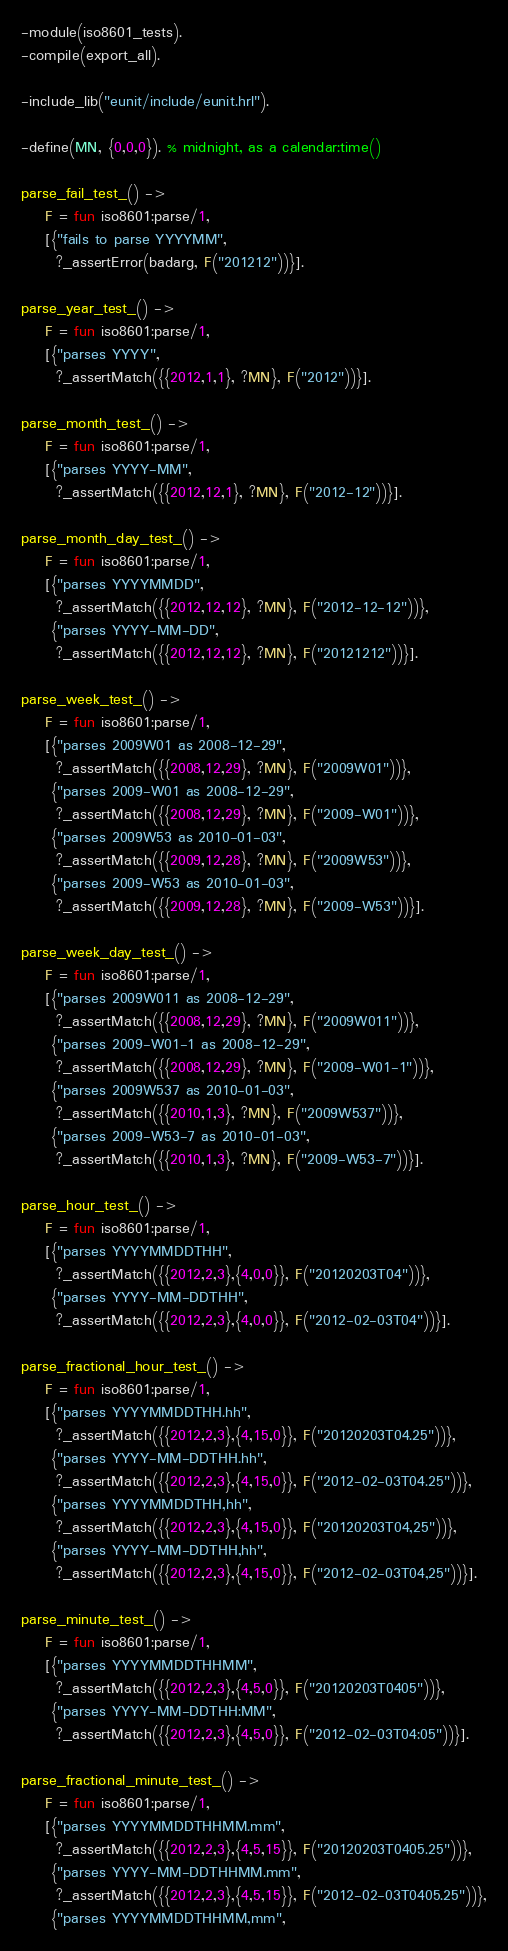Convert code to text. <code><loc_0><loc_0><loc_500><loc_500><_Erlang_>-module(iso8601_tests).
-compile(export_all).

-include_lib("eunit/include/eunit.hrl").

-define(MN, {0,0,0}). % midnight, as a calendar:time()

parse_fail_test_() ->
    F = fun iso8601:parse/1,
    [{"fails to parse YYYYMM",
      ?_assertError(badarg, F("201212"))}].

parse_year_test_() ->
    F = fun iso8601:parse/1,
    [{"parses YYYY",
      ?_assertMatch({{2012,1,1}, ?MN}, F("2012"))}].

parse_month_test_() ->
    F = fun iso8601:parse/1,
    [{"parses YYYY-MM",
      ?_assertMatch({{2012,12,1}, ?MN}, F("2012-12"))}].

parse_month_day_test_() ->
    F = fun iso8601:parse/1,
    [{"parses YYYYMMDD",
      ?_assertMatch({{2012,12,12}, ?MN}, F("2012-12-12"))},
     {"parses YYYY-MM-DD",
      ?_assertMatch({{2012,12,12}, ?MN}, F("20121212"))}].

parse_week_test_() ->
    F = fun iso8601:parse/1,
    [{"parses 2009W01 as 2008-12-29",
      ?_assertMatch({{2008,12,29}, ?MN}, F("2009W01"))},
     {"parses 2009-W01 as 2008-12-29",
      ?_assertMatch({{2008,12,29}, ?MN}, F("2009-W01"))},
     {"parses 2009W53 as 2010-01-03",
      ?_assertMatch({{2009,12,28}, ?MN}, F("2009W53"))},
     {"parses 2009-W53 as 2010-01-03",
      ?_assertMatch({{2009,12,28}, ?MN}, F("2009-W53"))}].

parse_week_day_test_() ->
    F = fun iso8601:parse/1,
    [{"parses 2009W011 as 2008-12-29",
      ?_assertMatch({{2008,12,29}, ?MN}, F("2009W011"))},
     {"parses 2009-W01-1 as 2008-12-29",
      ?_assertMatch({{2008,12,29}, ?MN}, F("2009-W01-1"))},
     {"parses 2009W537 as 2010-01-03",
      ?_assertMatch({{2010,1,3}, ?MN}, F("2009W537"))},
     {"parses 2009-W53-7 as 2010-01-03",
      ?_assertMatch({{2010,1,3}, ?MN}, F("2009-W53-7"))}].

parse_hour_test_() ->
    F = fun iso8601:parse/1,
    [{"parses YYYYMMDDTHH",
      ?_assertMatch({{2012,2,3},{4,0,0}}, F("20120203T04"))},
     {"parses YYYY-MM-DDTHH",
      ?_assertMatch({{2012,2,3},{4,0,0}}, F("2012-02-03T04"))}].

parse_fractional_hour_test_() ->
    F = fun iso8601:parse/1,
    [{"parses YYYYMMDDTHH.hh",
      ?_assertMatch({{2012,2,3},{4,15,0}}, F("20120203T04.25"))},
     {"parses YYYY-MM-DDTHH.hh",
      ?_assertMatch({{2012,2,3},{4,15,0}}, F("2012-02-03T04.25"))},
     {"parses YYYYMMDDTHH,hh",
      ?_assertMatch({{2012,2,3},{4,15,0}}, F("20120203T04,25"))},
     {"parses YYYY-MM-DDTHH,hh",
      ?_assertMatch({{2012,2,3},{4,15,0}}, F("2012-02-03T04,25"))}].

parse_minute_test_() ->
    F = fun iso8601:parse/1,
    [{"parses YYYYMMDDTHHMM",
      ?_assertMatch({{2012,2,3},{4,5,0}}, F("20120203T0405"))},
     {"parses YYYY-MM-DDTHH:MM",
      ?_assertMatch({{2012,2,3},{4,5,0}}, F("2012-02-03T04:05"))}].

parse_fractional_minute_test_() ->
    F = fun iso8601:parse/1,
    [{"parses YYYYMMDDTHHMM.mm",
      ?_assertMatch({{2012,2,3},{4,5,15}}, F("20120203T0405.25"))},
     {"parses YYYY-MM-DDTHHMM.mm",
      ?_assertMatch({{2012,2,3},{4,5,15}}, F("2012-02-03T0405.25"))},
     {"parses YYYYMMDDTHHMM,mm",</code> 